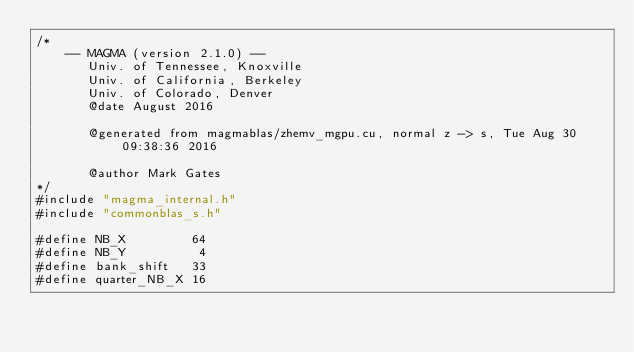Convert code to text. <code><loc_0><loc_0><loc_500><loc_500><_Cuda_>/*
    -- MAGMA (version 2.1.0) --
       Univ. of Tennessee, Knoxville
       Univ. of California, Berkeley
       Univ. of Colorado, Denver
       @date August 2016

       @generated from magmablas/zhemv_mgpu.cu, normal z -> s, Tue Aug 30 09:38:36 2016

       @author Mark Gates
*/
#include "magma_internal.h"
#include "commonblas_s.h"

#define NB_X         64
#define NB_Y          4
#define bank_shift   33
#define quarter_NB_X 16</code> 